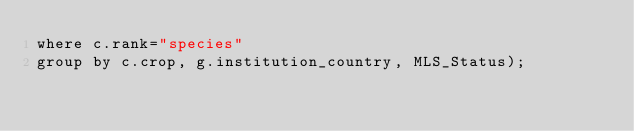Convert code to text. <code><loc_0><loc_0><loc_500><loc_500><_SQL_>where c.rank="species"
group by c.crop, g.institution_country, MLS_Status);



</code> 